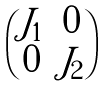<formula> <loc_0><loc_0><loc_500><loc_500>\begin{pmatrix} J _ { 1 } & 0 \\ 0 & J _ { 2 } \end{pmatrix}</formula> 